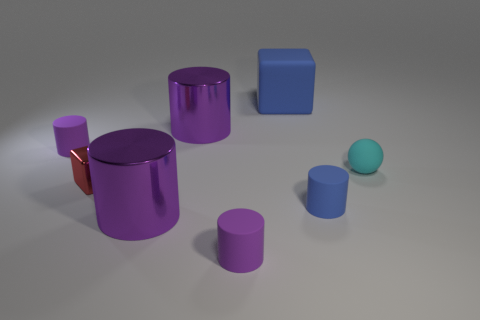Are any large blue matte cylinders visible?
Ensure brevity in your answer.  No. What is the material of the small purple object behind the large purple metal cylinder that is in front of the purple rubber cylinder on the left side of the tiny red metallic block?
Provide a short and direct response. Rubber. Are there fewer matte spheres in front of the blue cylinder than large red cylinders?
Offer a terse response. No. What material is the cyan thing that is the same size as the blue cylinder?
Your response must be concise. Rubber. There is a rubber object that is both behind the cyan matte thing and in front of the blue block; what is its size?
Provide a short and direct response. Small. The other metallic object that is the same shape as the large blue thing is what size?
Keep it short and to the point. Small. What number of things are shiny cylinders or big purple cylinders in front of the tiny cyan rubber ball?
Your response must be concise. 2. The tiny shiny object is what shape?
Offer a very short reply. Cube. What is the shape of the small cyan rubber object that is in front of the matte cylinder to the left of the red metal cube?
Provide a succinct answer. Sphere. There is a big block that is made of the same material as the cyan object; what color is it?
Your answer should be very brief. Blue. 